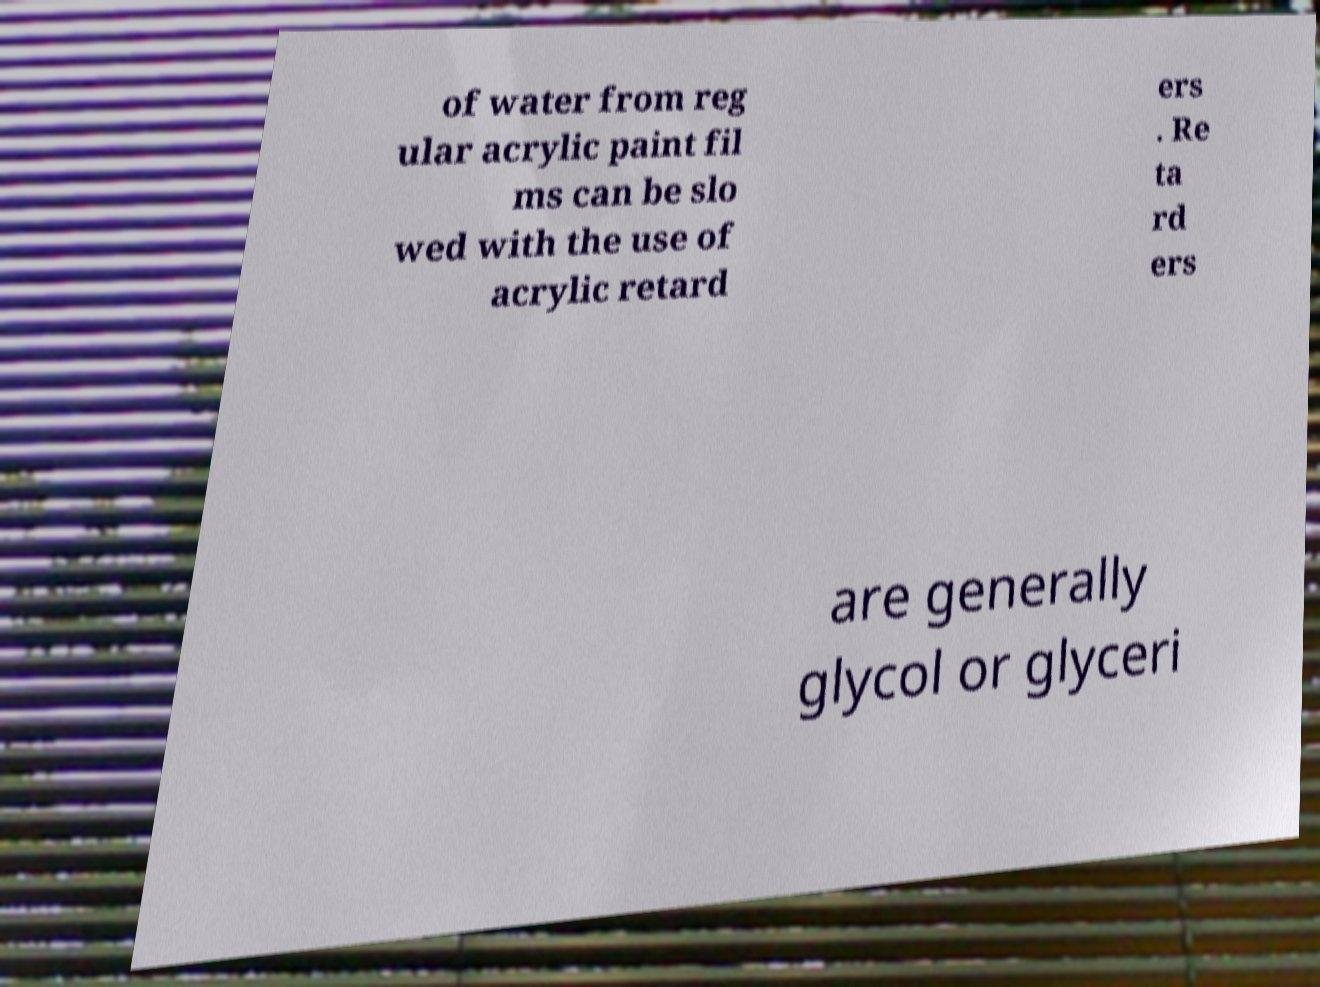There's text embedded in this image that I need extracted. Can you transcribe it verbatim? of water from reg ular acrylic paint fil ms can be slo wed with the use of acrylic retard ers . Re ta rd ers are generally glycol or glyceri 